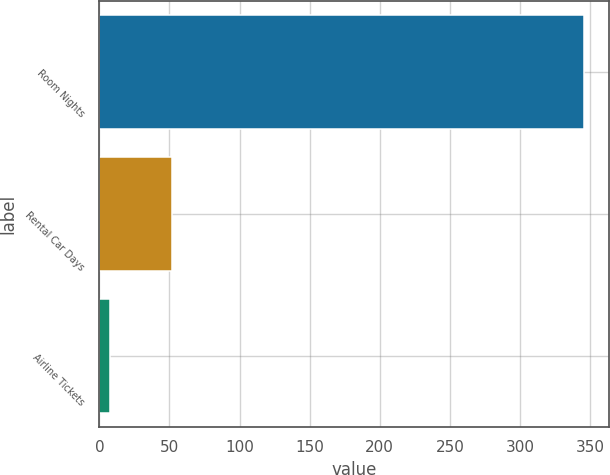Convert chart. <chart><loc_0><loc_0><loc_500><loc_500><bar_chart><fcel>Room Nights<fcel>Rental Car Days<fcel>Airline Tickets<nl><fcel>346<fcel>51.8<fcel>7.8<nl></chart> 